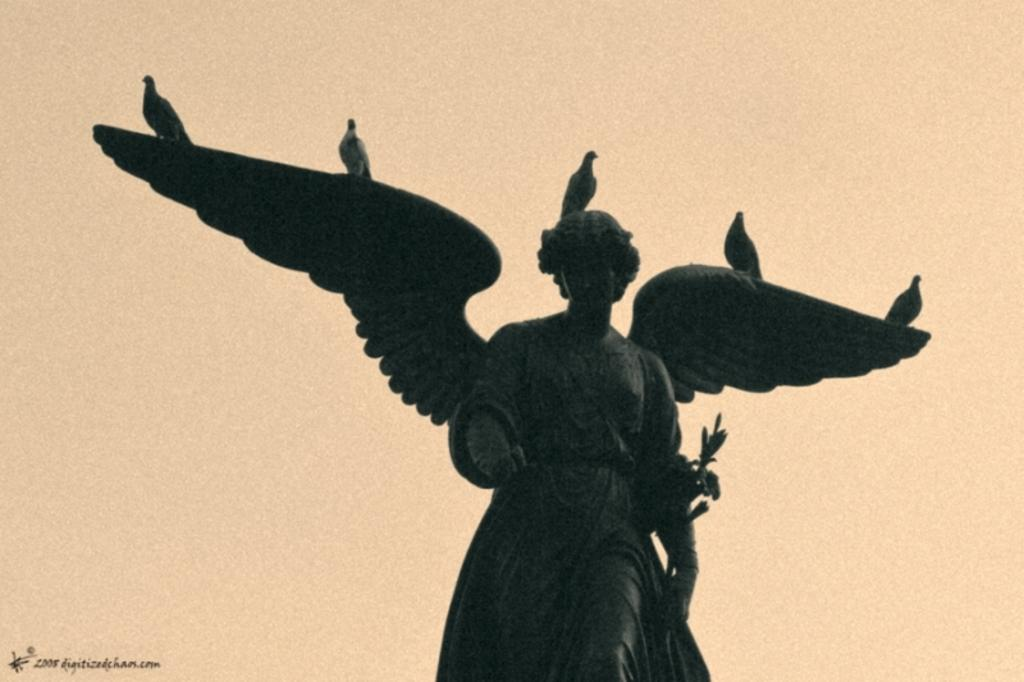What is depicted on the sculpture in the image? There are birds on a sculpture in the image. What is the color of the background in the image? The background color is cream. Where can text be found in the image? There is text in the bottom left side of the image. What type of basket is hanging from the birds in the image? There is no basket present in the image; it features birds on a sculpture with a cream background and text in the bottom left side. What is the weather like in the image? The image does not provide any information about the weather. 